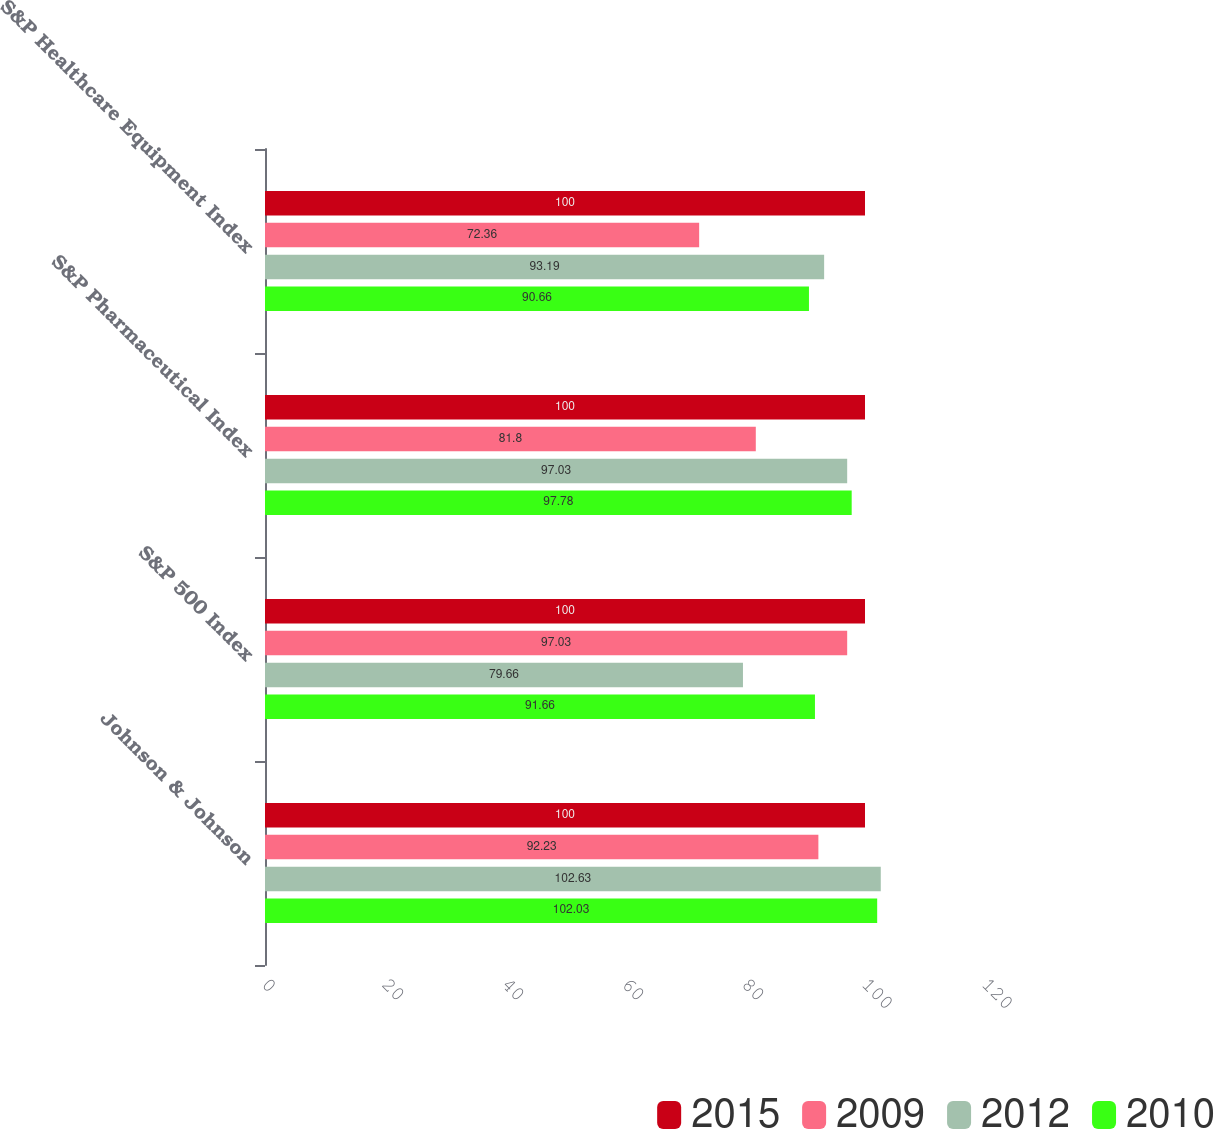Convert chart to OTSL. <chart><loc_0><loc_0><loc_500><loc_500><stacked_bar_chart><ecel><fcel>Johnson & Johnson<fcel>S&P 500 Index<fcel>S&P Pharmaceutical Index<fcel>S&P Healthcare Equipment Index<nl><fcel>2015<fcel>100<fcel>100<fcel>100<fcel>100<nl><fcel>2009<fcel>92.23<fcel>97.03<fcel>81.8<fcel>72.36<nl><fcel>2012<fcel>102.63<fcel>79.66<fcel>97.03<fcel>93.19<nl><fcel>2010<fcel>102.03<fcel>91.66<fcel>97.78<fcel>90.66<nl></chart> 